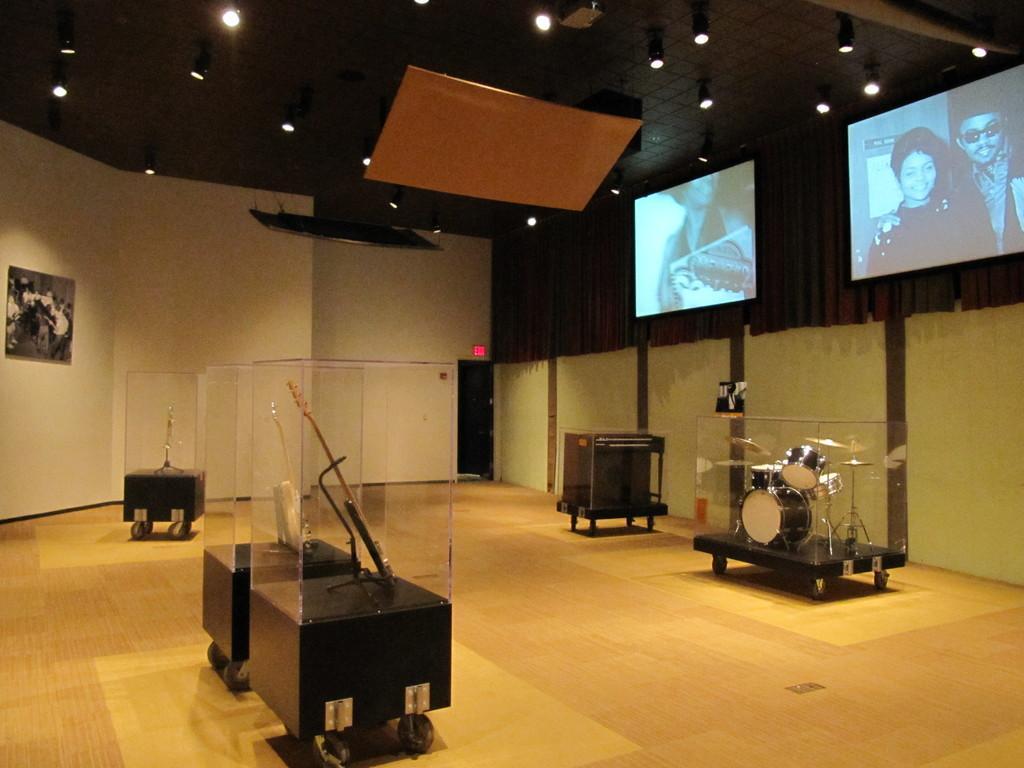Can you describe this image briefly? In this image we can see glass objects, musical instruments and other objects. In the background of the image there is a wall, screens and other objects. At the top of the image there is the ceiling, lights and other objects. At the bottom of the image there is the floor. 